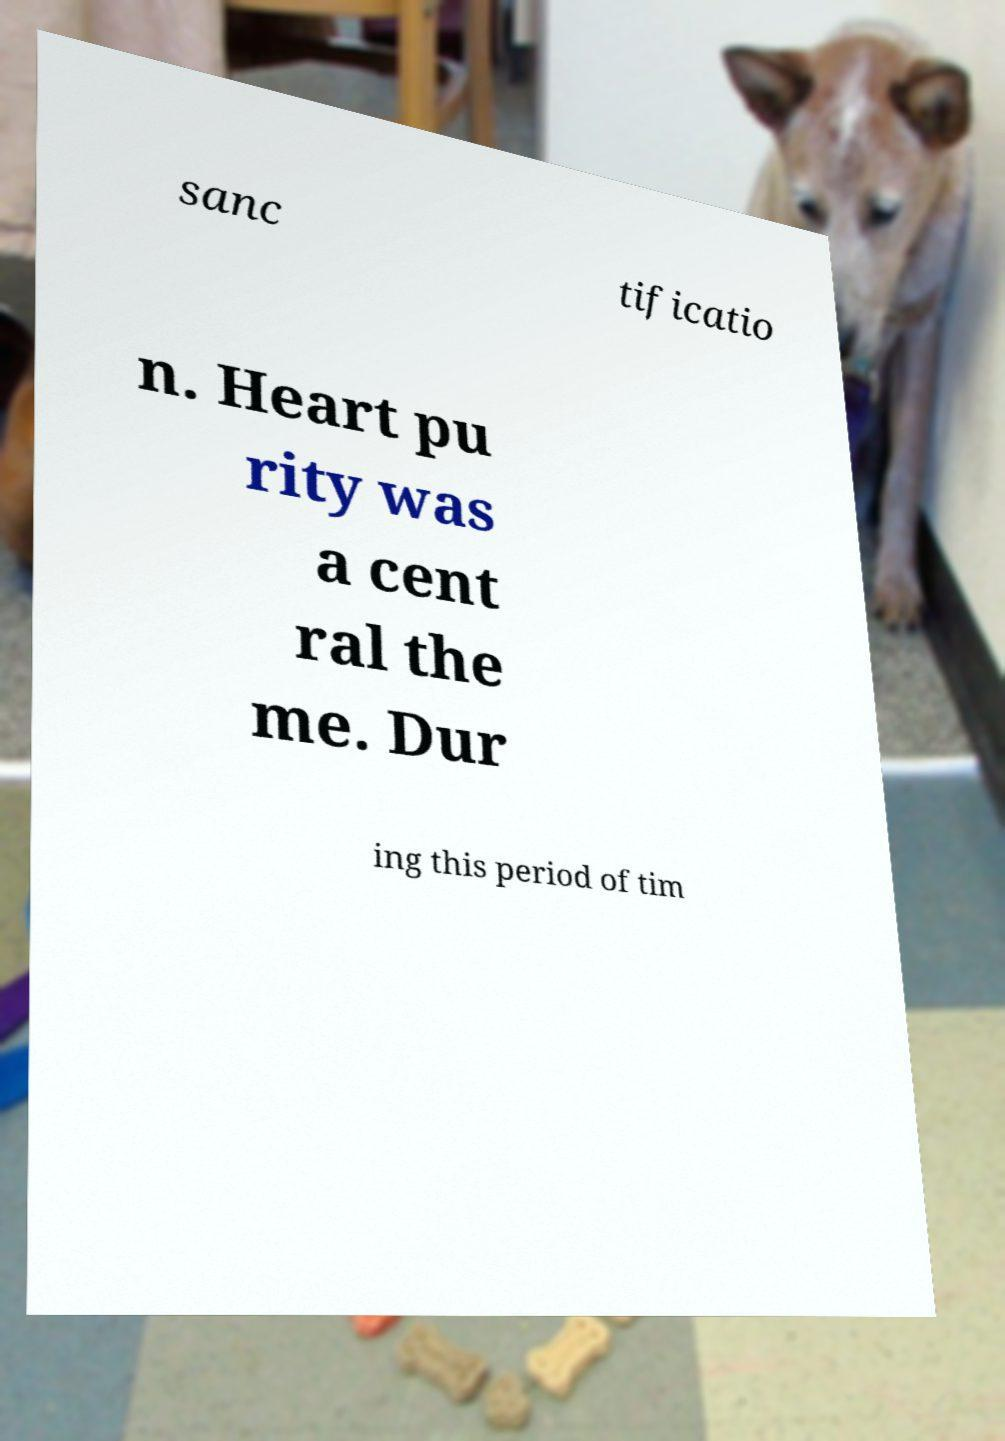Could you extract and type out the text from this image? sanc tificatio n. Heart pu rity was a cent ral the me. Dur ing this period of tim 